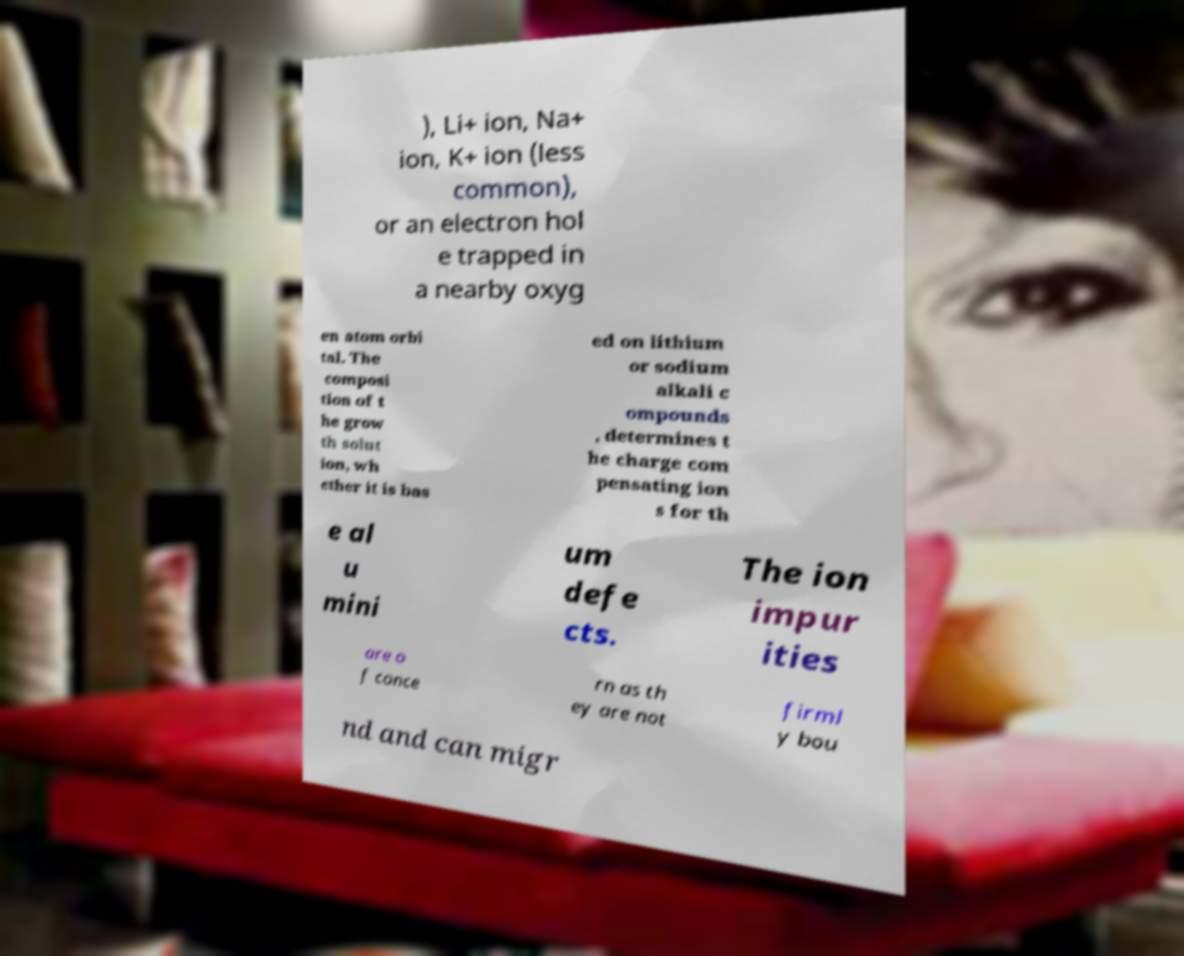For documentation purposes, I need the text within this image transcribed. Could you provide that? ), Li+ ion, Na+ ion, K+ ion (less common), or an electron hol e trapped in a nearby oxyg en atom orbi tal. The composi tion of t he grow th solut ion, wh ether it is bas ed on lithium or sodium alkali c ompounds , determines t he charge com pensating ion s for th e al u mini um defe cts. The ion impur ities are o f conce rn as th ey are not firml y bou nd and can migr 